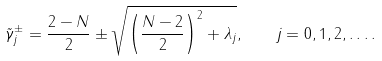Convert formula to latex. <formula><loc_0><loc_0><loc_500><loc_500>\tilde { \gamma } _ { j } ^ { \pm } = \frac { 2 - N } { 2 } \pm \sqrt { \left ( \frac { N - 2 } { 2 } \right ) ^ { 2 } + \lambda _ { j } } , \quad j = 0 , 1 , 2 , \dots .</formula> 